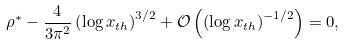Convert formula to latex. <formula><loc_0><loc_0><loc_500><loc_500>& \rho ^ { \ast } - \frac { 4 } { 3 \pi ^ { 2 } } \left ( \log x _ { t h } \right ) ^ { 3 / 2 } + \mathcal { O } \left ( \left ( \log x _ { t h } \right ) ^ { - 1 / 2 } \right ) = 0 ,</formula> 